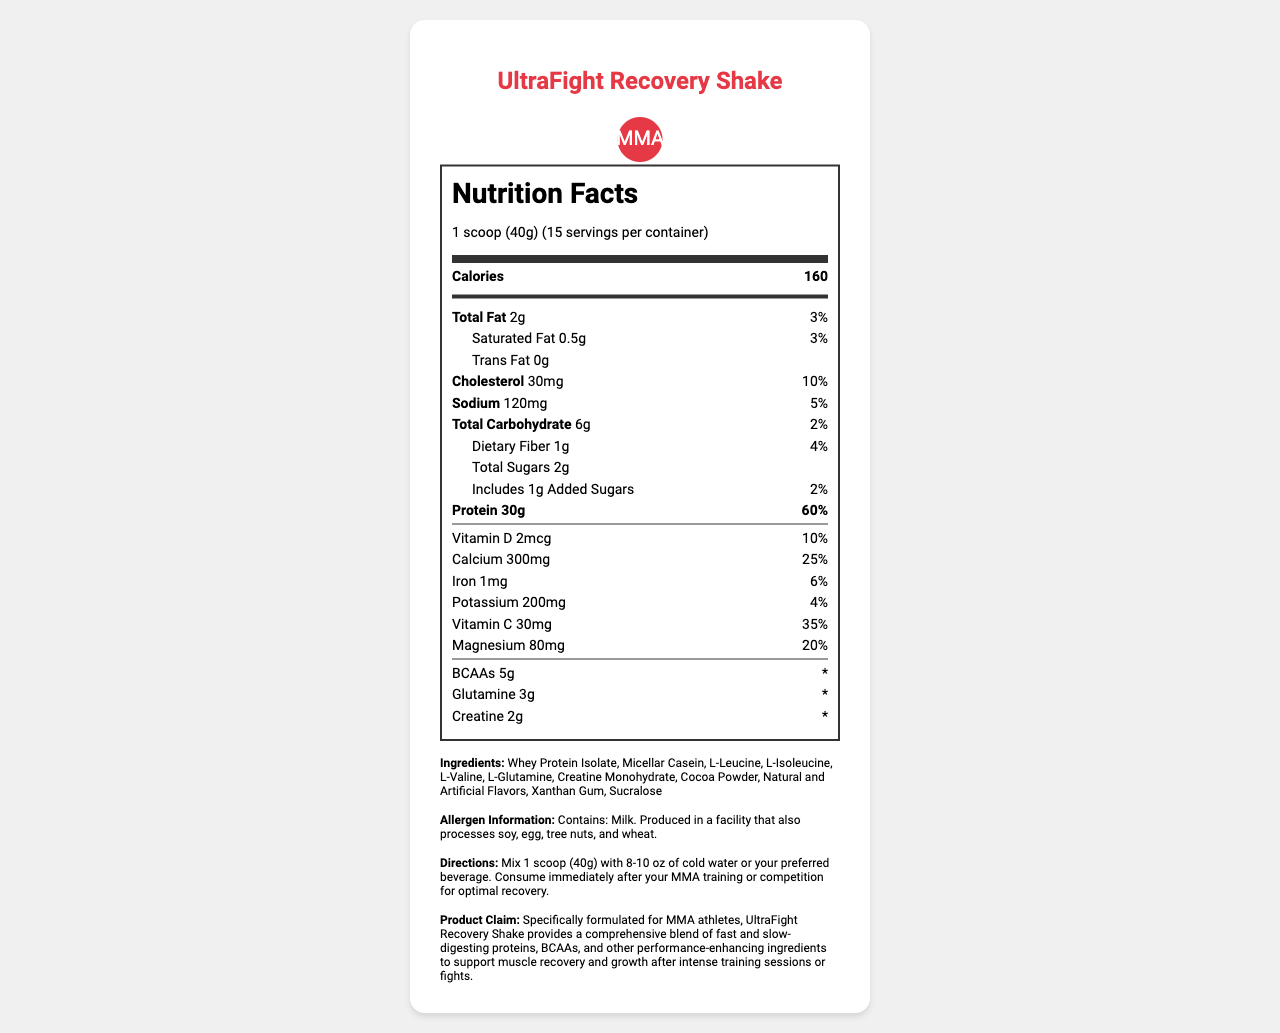what is the serving size for the UltraFight Recovery Shake? The serving size is specified at the beginning of the document as "1 scoop (40g)".
Answer: 1 scoop (40g) how many calories are in one serving of the UltraFight Recovery Shake? The document states that each serving contains 160 calories.
Answer: 160 what is the protein content per serving? The document lists the protein content as 30g per serving.
Answer: 30g how much total carbohydrate does one serving contain? The document specifies that each serving contains 6g of total carbohydrates.
Answer: 6g what are the added sugars in one serving? The document indicates that each serving includes 1g of added sugars.
Answer: 1g does this product contain any allergens? The document states in the allergen information section that it contains milk and is produced in a facility that processes soy, egg, tree nuts, and wheat.
Answer: Yes how many servings are there per container? The document specifies that there are 15 servings per container.
Answer: 15 what is the main ingredient in this product? The first ingredient listed is usually the main one, which is Whey Protein Isolate.
Answer: Whey Protein Isolate what percentage of daily value for calcium does one serving provide? The document shows that one serving provides 25% of the daily value for calcium.
Answer: 25% which component is present in the least amount in terms of daily value percentage? A. Vitamin D B. Iron C. Magnesium D. Potassium Iron has the least daily value at 6%, while Vitamin D has 10%, Magnesium has 20%, and Potassium has 4%.
Answer: B what is the daily value percentage of protein provided by one serving? A. 40% B. 50% C. 60% D. 70% The document specifies that one serving provides 60% of the daily value for protein.
Answer: C is there any trans fat in this product? The document lists the trans fat content as 0g.
Answer: No summarize the key nutritional benefits of the UltraFight Recovery Shake. This summary captures the main nutritional features and claims of the product as described in the document.
Answer: The UltraFight Recovery Shake provides high protein (30g) with 160 calories per serving along with essential amino acids, BCAAs, and specific vitamins and minerals like calcium, magnesium, and vitamin C. It is specially formulated for MMA athletes to aid muscle recovery and growth. what is the amount of glutamine per serving in the UltraFight Recovery Shake? The document clearly lists the amount of glutamine as 3g per serving.
Answer: 3g can the exact impact of creatine on a daily nutrition plan be determined from this document? The daily value percentage for creatine is not provided, so the exact impact on a daily nutrition plan cannot be determined from the document.
Answer: Cannot be determined what flavorings are used in this product? The ingredient list in the document mentions "Natural and Artificial Flavors".
Answer: Natural and Artificial Flavors 